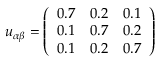Convert formula to latex. <formula><loc_0><loc_0><loc_500><loc_500>u _ { \alpha \beta } = \left ( \begin{array} { l l l } { 0 . 7 } & { 0 . 2 } & { 0 . 1 } \\ { 0 . 1 } & { 0 . 7 } & { 0 . 2 } \\ { 0 . 1 } & { 0 . 2 } & { 0 . 7 } \end{array} \right )</formula> 